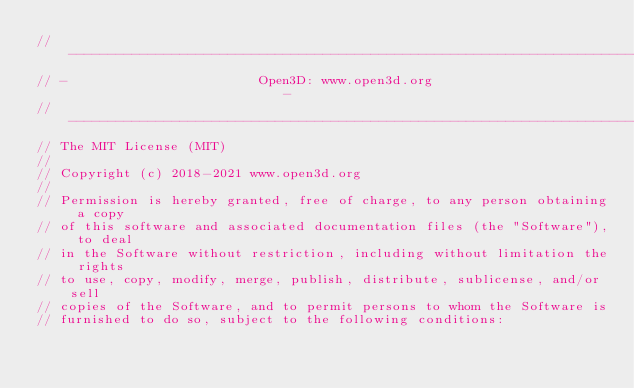Convert code to text. <code><loc_0><loc_0><loc_500><loc_500><_C_>// ----------------------------------------------------------------------------
// -                        Open3D: www.open3d.org                            -
// ----------------------------------------------------------------------------
// The MIT License (MIT)
//
// Copyright (c) 2018-2021 www.open3d.org
//
// Permission is hereby granted, free of charge, to any person obtaining a copy
// of this software and associated documentation files (the "Software"), to deal
// in the Software without restriction, including without limitation the rights
// to use, copy, modify, merge, publish, distribute, sublicense, and/or sell
// copies of the Software, and to permit persons to whom the Software is
// furnished to do so, subject to the following conditions:</code> 